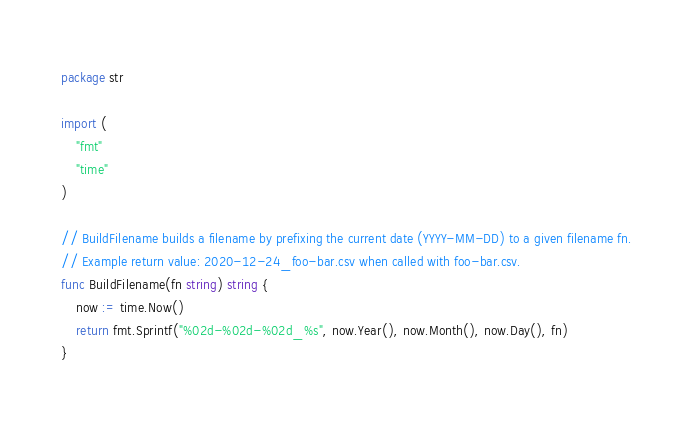<code> <loc_0><loc_0><loc_500><loc_500><_Go_>package str

import (
	"fmt"
	"time"
)

// BuildFilename builds a filename by prefixing the current date (YYYY-MM-DD) to a given filename fn.
// Example return value: 2020-12-24_foo-bar.csv when called with foo-bar.csv.
func BuildFilename(fn string) string {
	now := time.Now()
	return fmt.Sprintf("%02d-%02d-%02d_%s", now.Year(), now.Month(), now.Day(), fn)
}
</code> 